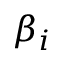<formula> <loc_0><loc_0><loc_500><loc_500>\beta _ { i }</formula> 